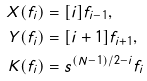Convert formula to latex. <formula><loc_0><loc_0><loc_500><loc_500>X ( f _ { i } ) & = [ i ] f _ { i - 1 } , \\ Y ( f _ { i } ) & = [ i + 1 ] f _ { i + 1 } , \\ K ( f _ { i } ) & = s ^ { ( N - 1 ) / 2 - i } f _ { i }</formula> 